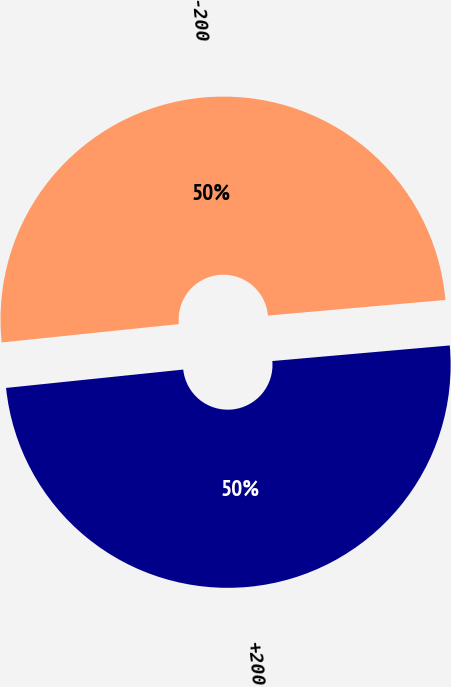Convert chart to OTSL. <chart><loc_0><loc_0><loc_500><loc_500><pie_chart><fcel>+200<fcel>-200<nl><fcel>49.75%<fcel>50.25%<nl></chart> 